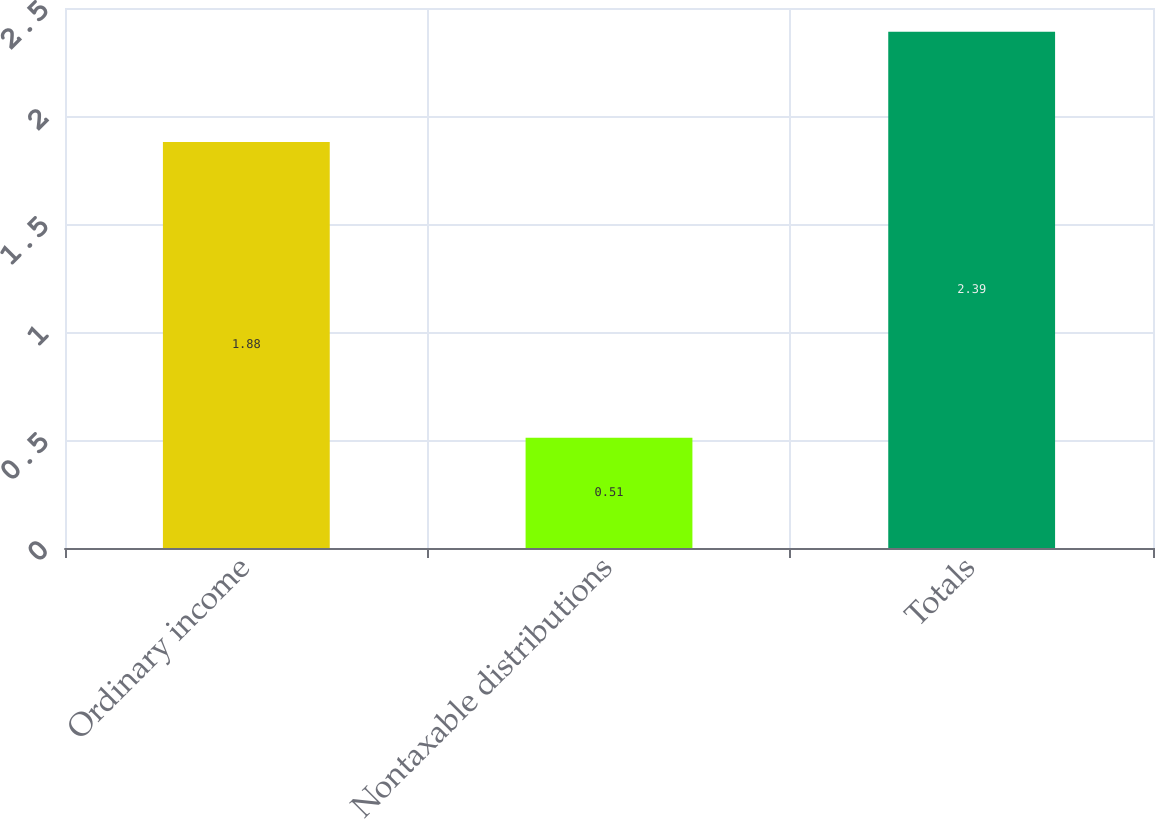Convert chart to OTSL. <chart><loc_0><loc_0><loc_500><loc_500><bar_chart><fcel>Ordinary income<fcel>Nontaxable distributions<fcel>Totals<nl><fcel>1.88<fcel>0.51<fcel>2.39<nl></chart> 